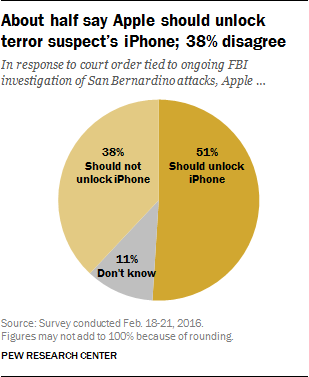Highlight a few significant elements in this photo. Approximately 4.9% of people do not choose to unlock their iPhone. The most widely held view in the chart is that iPhone users should be allowed to unlock their devices. 